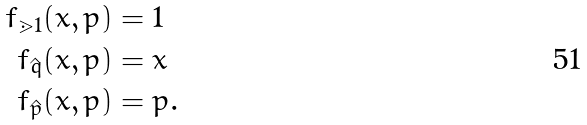<formula> <loc_0><loc_0><loc_500><loc_500>f _ { \mathbb { m } { 1 } } ( x , p ) & = 1 \\ f _ { \hat { q } } ( x , p ) & = x \\ f _ { \hat { p } } ( x , p ) & = p .</formula> 